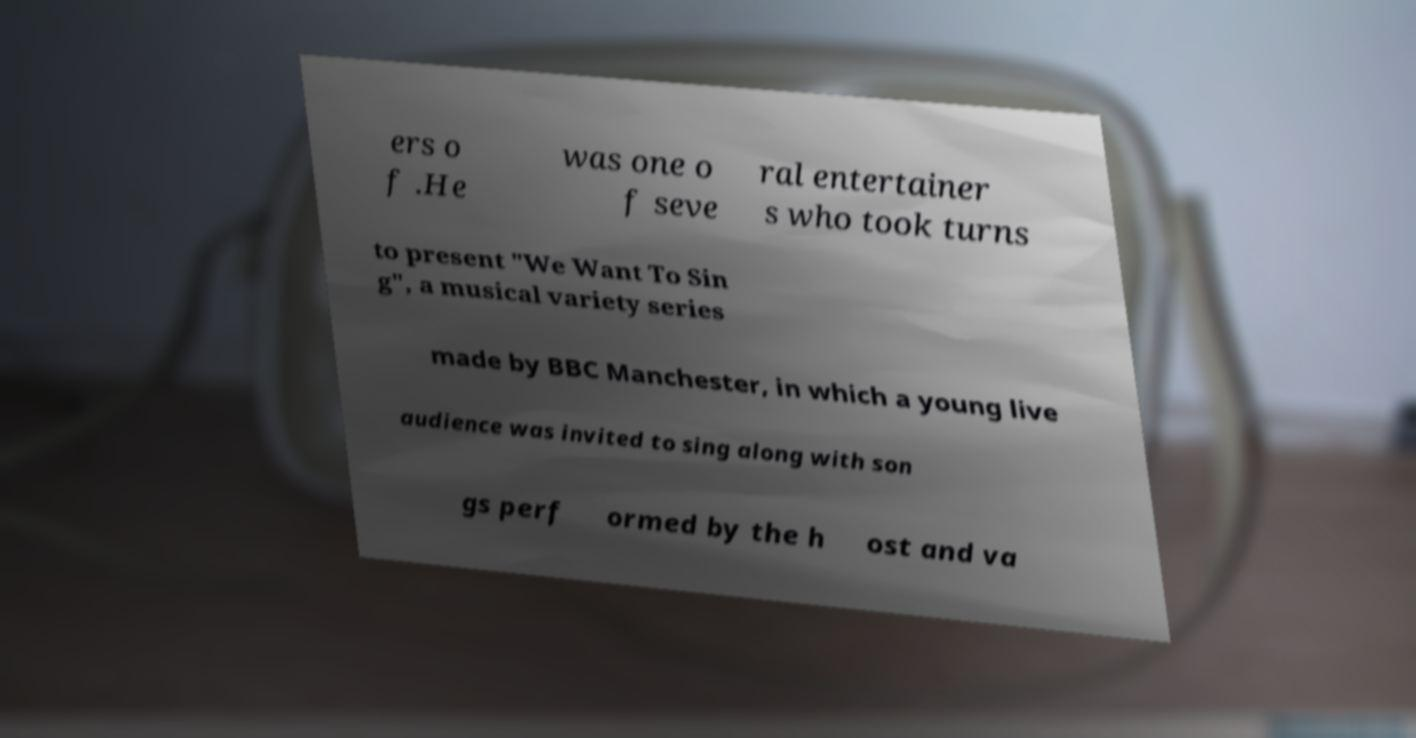There's text embedded in this image that I need extracted. Can you transcribe it verbatim? ers o f .He was one o f seve ral entertainer s who took turns to present "We Want To Sin g", a musical variety series made by BBC Manchester, in which a young live audience was invited to sing along with son gs perf ormed by the h ost and va 